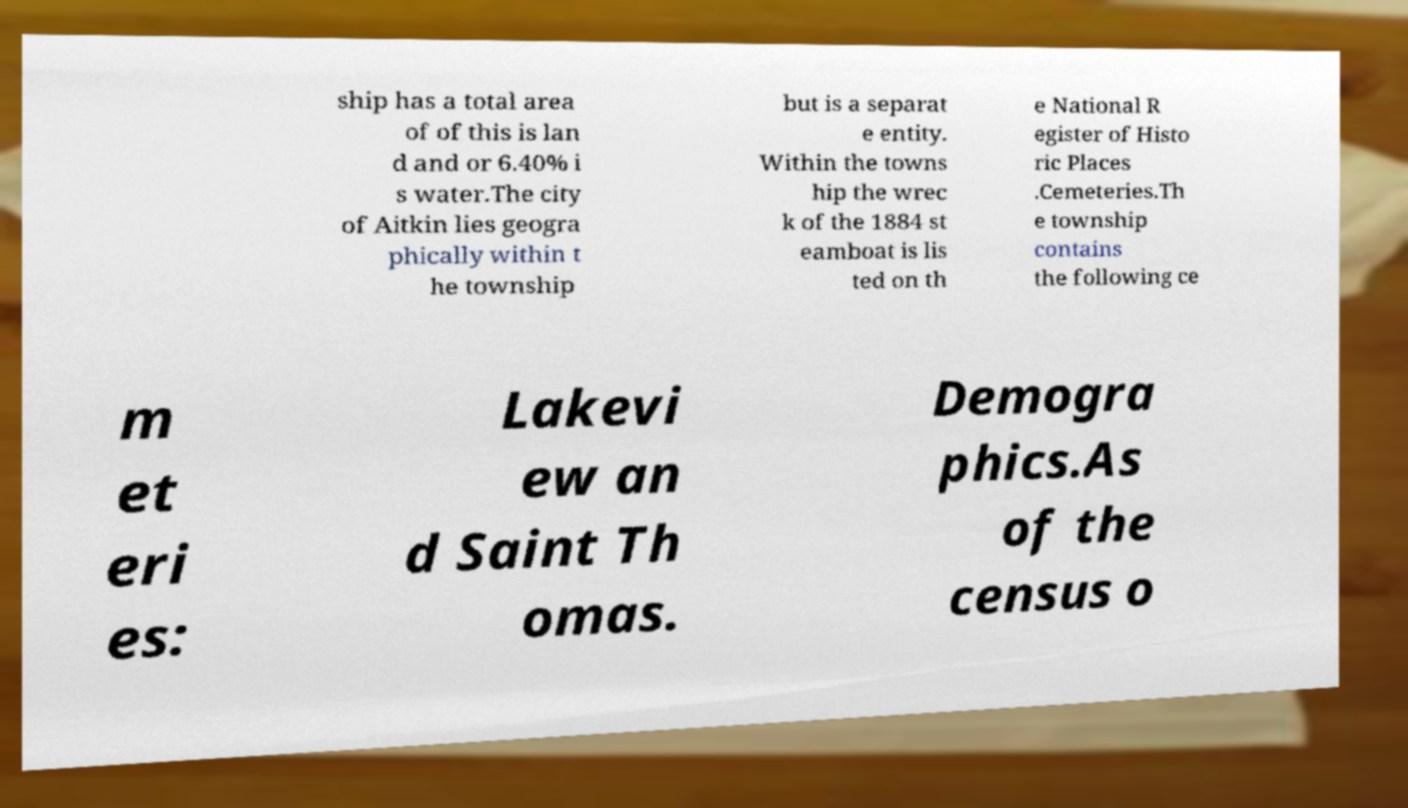Can you accurately transcribe the text from the provided image for me? ship has a total area of of this is lan d and or 6.40% i s water.The city of Aitkin lies geogra phically within t he township but is a separat e entity. Within the towns hip the wrec k of the 1884 st eamboat is lis ted on th e National R egister of Histo ric Places .Cemeteries.Th e township contains the following ce m et eri es: Lakevi ew an d Saint Th omas. Demogra phics.As of the census o 